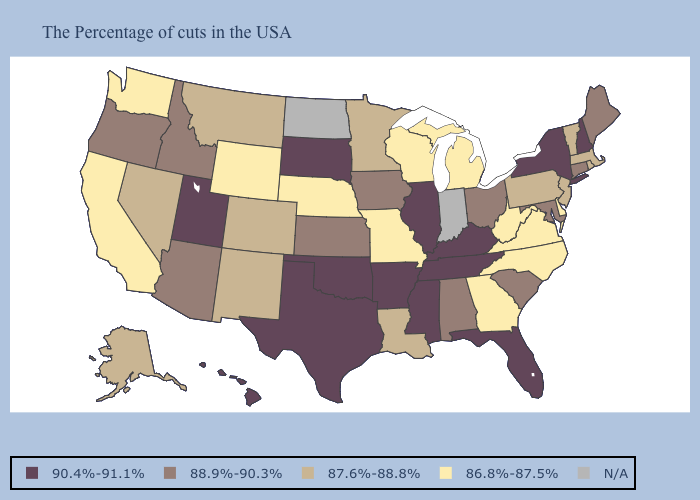Does South Dakota have the highest value in the MidWest?
Write a very short answer. Yes. What is the lowest value in the USA?
Write a very short answer. 86.8%-87.5%. What is the value of Louisiana?
Short answer required. 87.6%-88.8%. Name the states that have a value in the range 86.8%-87.5%?
Give a very brief answer. Delaware, Virginia, North Carolina, West Virginia, Georgia, Michigan, Wisconsin, Missouri, Nebraska, Wyoming, California, Washington. How many symbols are there in the legend?
Short answer required. 5. Is the legend a continuous bar?
Write a very short answer. No. Does the first symbol in the legend represent the smallest category?
Give a very brief answer. No. Name the states that have a value in the range N/A?
Answer briefly. Indiana, North Dakota. What is the value of Alaska?
Give a very brief answer. 87.6%-88.8%. Does Washington have the lowest value in the West?
Be succinct. Yes. Name the states that have a value in the range 87.6%-88.8%?
Quick response, please. Massachusetts, Rhode Island, Vermont, New Jersey, Pennsylvania, Louisiana, Minnesota, Colorado, New Mexico, Montana, Nevada, Alaska. Which states hav the highest value in the Northeast?
Concise answer only. New Hampshire, New York. Name the states that have a value in the range 87.6%-88.8%?
Short answer required. Massachusetts, Rhode Island, Vermont, New Jersey, Pennsylvania, Louisiana, Minnesota, Colorado, New Mexico, Montana, Nevada, Alaska. 